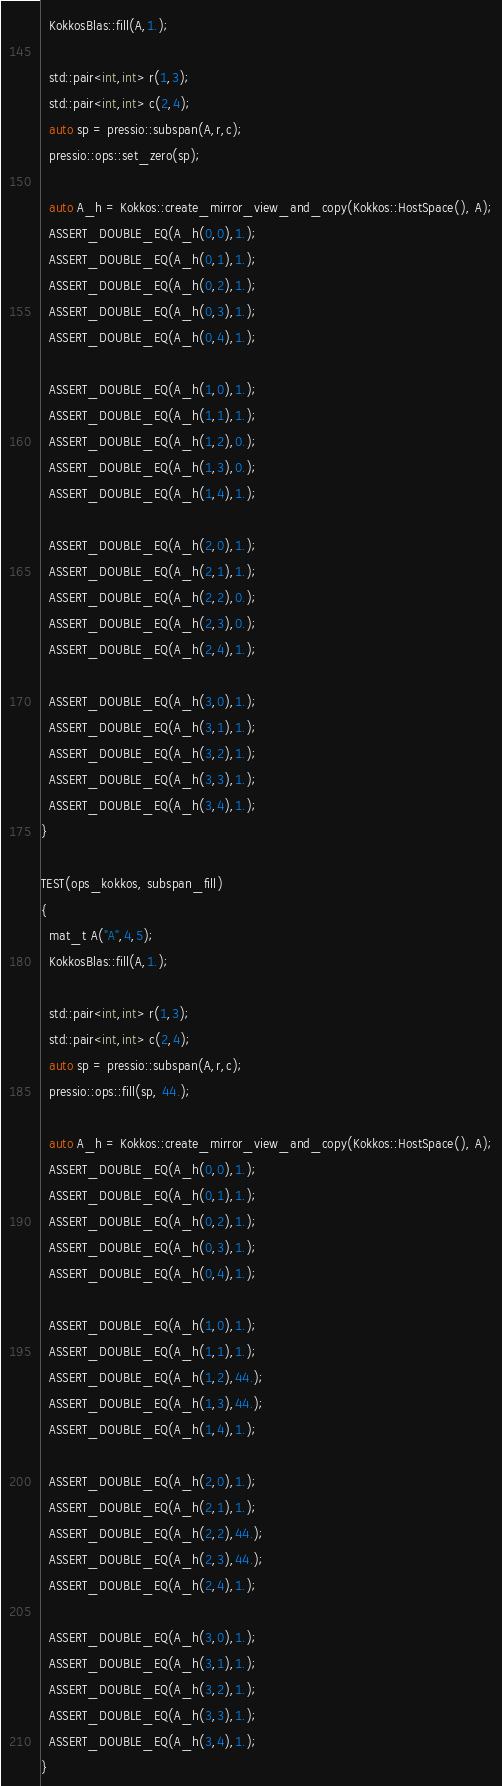Convert code to text. <code><loc_0><loc_0><loc_500><loc_500><_C++_>  KokkosBlas::fill(A,1.);

  std::pair<int,int> r(1,3);
  std::pair<int,int> c(2,4);
  auto sp = pressio::subspan(A,r,c);
  pressio::ops::set_zero(sp);

  auto A_h = Kokkos::create_mirror_view_and_copy(Kokkos::HostSpace(), A);
  ASSERT_DOUBLE_EQ(A_h(0,0),1.);
  ASSERT_DOUBLE_EQ(A_h(0,1),1.);
  ASSERT_DOUBLE_EQ(A_h(0,2),1.);
  ASSERT_DOUBLE_EQ(A_h(0,3),1.);
  ASSERT_DOUBLE_EQ(A_h(0,4),1.);

  ASSERT_DOUBLE_EQ(A_h(1,0),1.);
  ASSERT_DOUBLE_EQ(A_h(1,1),1.);
  ASSERT_DOUBLE_EQ(A_h(1,2),0.);
  ASSERT_DOUBLE_EQ(A_h(1,3),0.);
  ASSERT_DOUBLE_EQ(A_h(1,4),1.);

  ASSERT_DOUBLE_EQ(A_h(2,0),1.);
  ASSERT_DOUBLE_EQ(A_h(2,1),1.);
  ASSERT_DOUBLE_EQ(A_h(2,2),0.);
  ASSERT_DOUBLE_EQ(A_h(2,3),0.);
  ASSERT_DOUBLE_EQ(A_h(2,4),1.);

  ASSERT_DOUBLE_EQ(A_h(3,0),1.);
  ASSERT_DOUBLE_EQ(A_h(3,1),1.);
  ASSERT_DOUBLE_EQ(A_h(3,2),1.);
  ASSERT_DOUBLE_EQ(A_h(3,3),1.);
  ASSERT_DOUBLE_EQ(A_h(3,4),1.);
}

TEST(ops_kokkos, subspan_fill)
{
  mat_t A("A",4,5);
  KokkosBlas::fill(A,1.);

  std::pair<int,int> r(1,3);
  std::pair<int,int> c(2,4);
  auto sp = pressio::subspan(A,r,c);
  pressio::ops::fill(sp, 44.);

  auto A_h = Kokkos::create_mirror_view_and_copy(Kokkos::HostSpace(), A);
  ASSERT_DOUBLE_EQ(A_h(0,0),1.);
  ASSERT_DOUBLE_EQ(A_h(0,1),1.);
  ASSERT_DOUBLE_EQ(A_h(0,2),1.);
  ASSERT_DOUBLE_EQ(A_h(0,3),1.);
  ASSERT_DOUBLE_EQ(A_h(0,4),1.);

  ASSERT_DOUBLE_EQ(A_h(1,0),1.);
  ASSERT_DOUBLE_EQ(A_h(1,1),1.);
  ASSERT_DOUBLE_EQ(A_h(1,2),44.);
  ASSERT_DOUBLE_EQ(A_h(1,3),44.);
  ASSERT_DOUBLE_EQ(A_h(1,4),1.);

  ASSERT_DOUBLE_EQ(A_h(2,0),1.);
  ASSERT_DOUBLE_EQ(A_h(2,1),1.);
  ASSERT_DOUBLE_EQ(A_h(2,2),44.);
  ASSERT_DOUBLE_EQ(A_h(2,3),44.);
  ASSERT_DOUBLE_EQ(A_h(2,4),1.);

  ASSERT_DOUBLE_EQ(A_h(3,0),1.);
  ASSERT_DOUBLE_EQ(A_h(3,1),1.);
  ASSERT_DOUBLE_EQ(A_h(3,2),1.);
  ASSERT_DOUBLE_EQ(A_h(3,3),1.);
  ASSERT_DOUBLE_EQ(A_h(3,4),1.);
}
</code> 